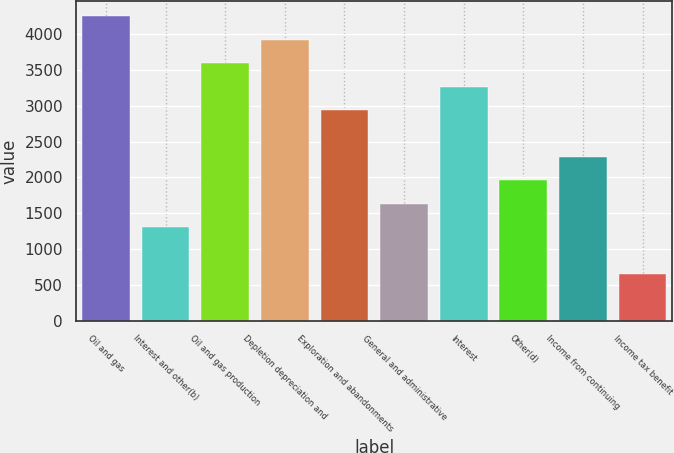Convert chart to OTSL. <chart><loc_0><loc_0><loc_500><loc_500><bar_chart><fcel>Oil and gas<fcel>Interest and other(b)<fcel>Oil and gas production<fcel>Depletion depreciation and<fcel>Exploration and abandonments<fcel>General and administrative<fcel>Interest<fcel>Other(d)<fcel>Income from continuing<fcel>Income tax benefit<nl><fcel>4252.14<fcel>1308.96<fcel>3598.1<fcel>3925.12<fcel>2944.06<fcel>1635.98<fcel>3271.08<fcel>1963<fcel>2290.02<fcel>654.92<nl></chart> 